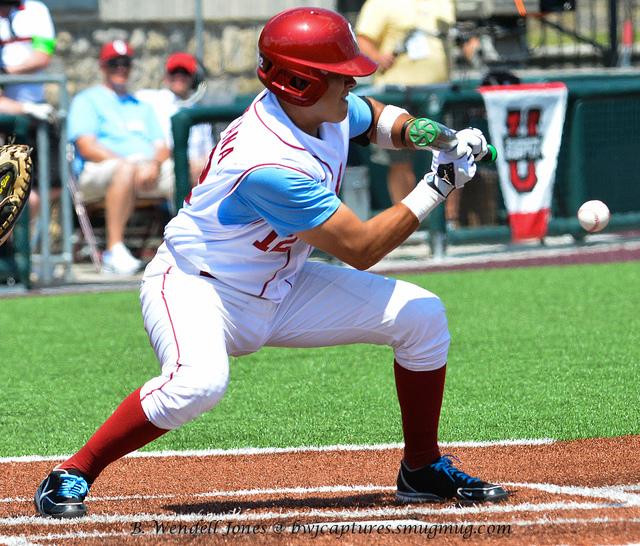What color is the man's socks?
Concise answer only. Red. What is the man getting ready to do to the ball?
Write a very short answer. Hit it. Has the ball been hit yet?
Be succinct. No. What color is on the end of the baseball bat?
Short answer required. Green. 